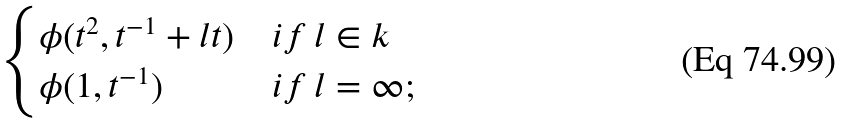Convert formula to latex. <formula><loc_0><loc_0><loc_500><loc_500>\begin{cases} \phi ( t ^ { 2 } , t ^ { - 1 } + l t ) & i f \, l \in k \\ \phi ( 1 , t ^ { - 1 } ) & i f \, l = \infty ; \end{cases}</formula> 